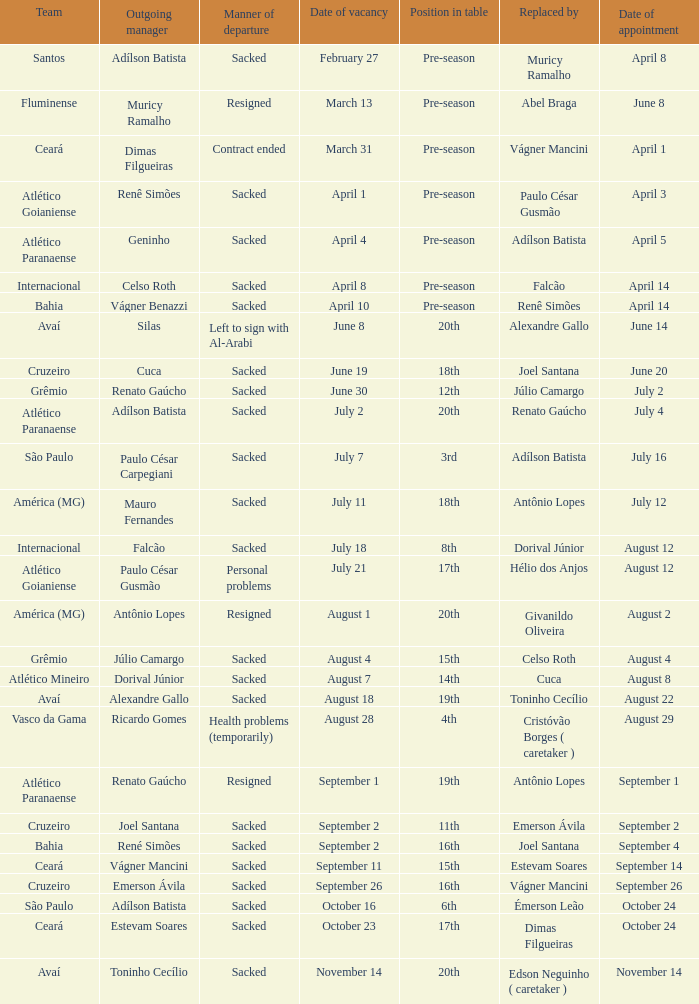Who was succeeded as the manager on the 20th of june? Cuca. 